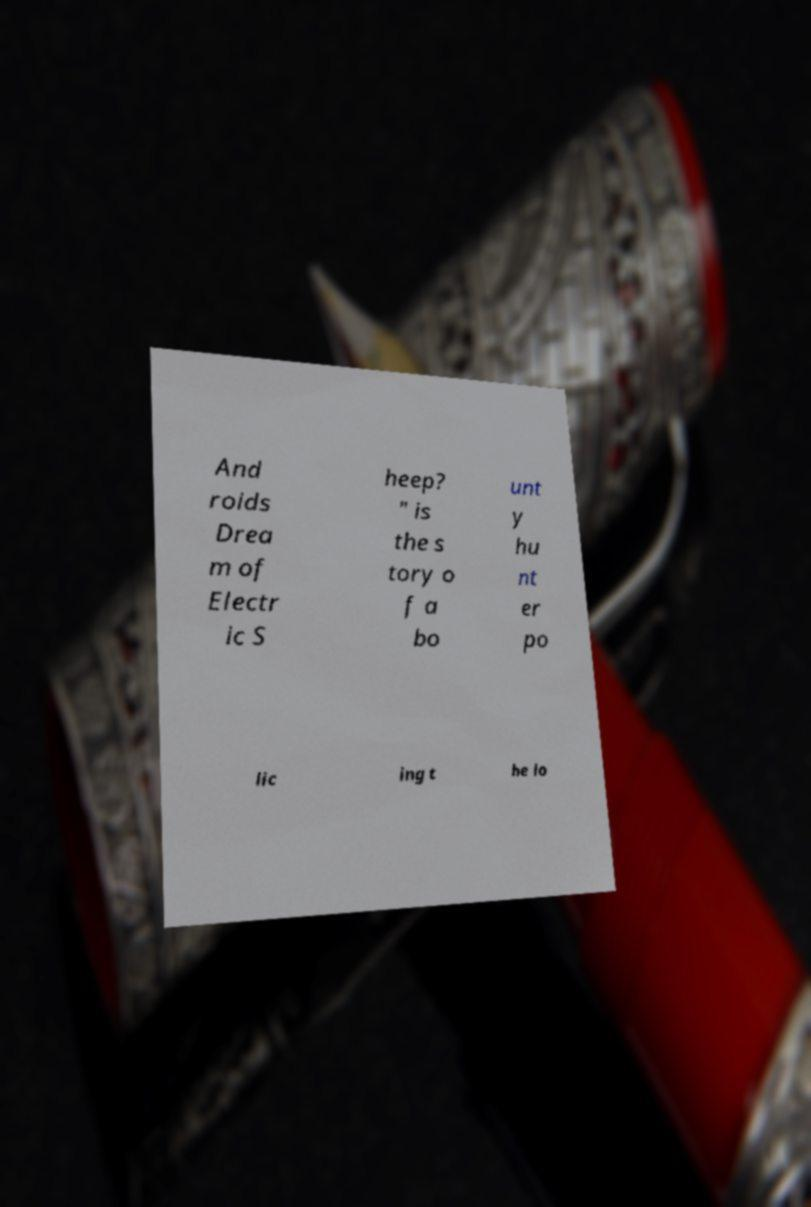Please identify and transcribe the text found in this image. And roids Drea m of Electr ic S heep? " is the s tory o f a bo unt y hu nt er po lic ing t he lo 